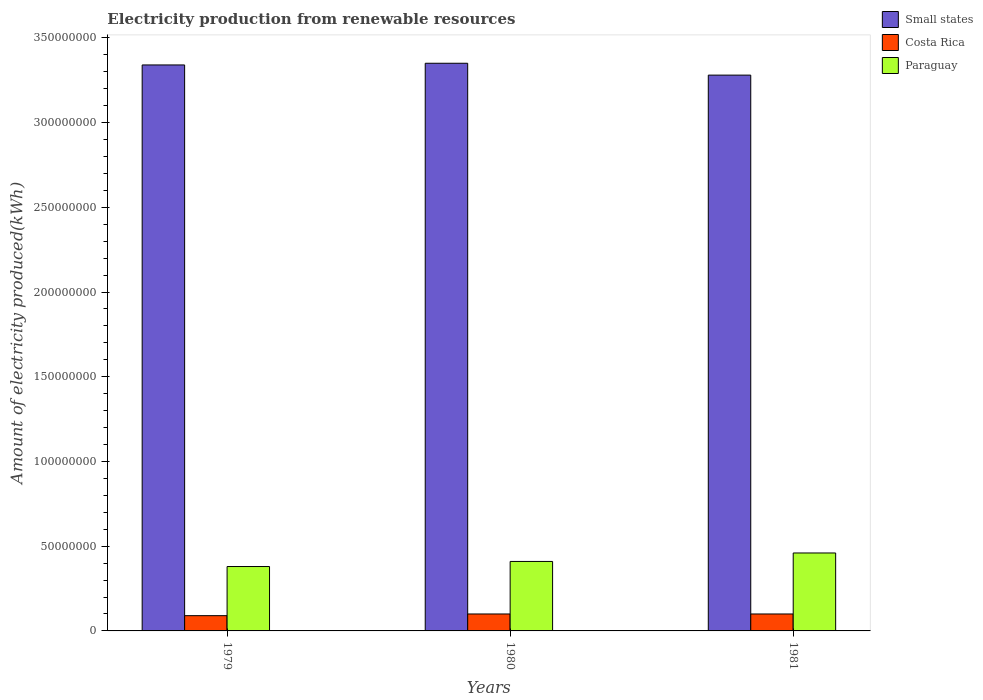How many different coloured bars are there?
Your response must be concise. 3. Are the number of bars on each tick of the X-axis equal?
Offer a very short reply. Yes. How many bars are there on the 3rd tick from the left?
Offer a terse response. 3. How many bars are there on the 1st tick from the right?
Keep it short and to the point. 3. What is the label of the 1st group of bars from the left?
Your response must be concise. 1979. In how many cases, is the number of bars for a given year not equal to the number of legend labels?
Your answer should be compact. 0. What is the amount of electricity produced in Costa Rica in 1980?
Your response must be concise. 1.00e+07. Across all years, what is the minimum amount of electricity produced in Costa Rica?
Your response must be concise. 9.00e+06. In which year was the amount of electricity produced in Costa Rica minimum?
Your answer should be compact. 1979. What is the total amount of electricity produced in Small states in the graph?
Provide a short and direct response. 9.97e+08. What is the difference between the amount of electricity produced in Small states in 1979 and that in 1981?
Offer a very short reply. 6.00e+06. What is the difference between the amount of electricity produced in Costa Rica in 1981 and the amount of electricity produced in Paraguay in 1979?
Provide a succinct answer. -2.80e+07. What is the average amount of electricity produced in Costa Rica per year?
Your answer should be very brief. 9.67e+06. In the year 1979, what is the difference between the amount of electricity produced in Costa Rica and amount of electricity produced in Small states?
Provide a short and direct response. -3.25e+08. In how many years, is the amount of electricity produced in Paraguay greater than 50000000 kWh?
Your answer should be compact. 0. Is the difference between the amount of electricity produced in Costa Rica in 1980 and 1981 greater than the difference between the amount of electricity produced in Small states in 1980 and 1981?
Keep it short and to the point. No. What is the difference between the highest and the second highest amount of electricity produced in Small states?
Your response must be concise. 1.00e+06. What is the difference between the highest and the lowest amount of electricity produced in Small states?
Offer a very short reply. 7.00e+06. In how many years, is the amount of electricity produced in Small states greater than the average amount of electricity produced in Small states taken over all years?
Your answer should be very brief. 2. Is the sum of the amount of electricity produced in Paraguay in 1979 and 1980 greater than the maximum amount of electricity produced in Costa Rica across all years?
Your answer should be very brief. Yes. What does the 3rd bar from the left in 1979 represents?
Your answer should be very brief. Paraguay. What does the 2nd bar from the right in 1981 represents?
Your answer should be very brief. Costa Rica. Is it the case that in every year, the sum of the amount of electricity produced in Paraguay and amount of electricity produced in Costa Rica is greater than the amount of electricity produced in Small states?
Your answer should be very brief. No. Are all the bars in the graph horizontal?
Your answer should be very brief. No. Are the values on the major ticks of Y-axis written in scientific E-notation?
Make the answer very short. No. Does the graph contain any zero values?
Offer a very short reply. No. Where does the legend appear in the graph?
Offer a very short reply. Top right. How many legend labels are there?
Provide a succinct answer. 3. How are the legend labels stacked?
Offer a terse response. Vertical. What is the title of the graph?
Your answer should be compact. Electricity production from renewable resources. What is the label or title of the Y-axis?
Provide a succinct answer. Amount of electricity produced(kWh). What is the Amount of electricity produced(kWh) in Small states in 1979?
Your answer should be very brief. 3.34e+08. What is the Amount of electricity produced(kWh) in Costa Rica in 1979?
Ensure brevity in your answer.  9.00e+06. What is the Amount of electricity produced(kWh) of Paraguay in 1979?
Ensure brevity in your answer.  3.80e+07. What is the Amount of electricity produced(kWh) in Small states in 1980?
Provide a short and direct response. 3.35e+08. What is the Amount of electricity produced(kWh) of Costa Rica in 1980?
Give a very brief answer. 1.00e+07. What is the Amount of electricity produced(kWh) of Paraguay in 1980?
Ensure brevity in your answer.  4.10e+07. What is the Amount of electricity produced(kWh) in Small states in 1981?
Your answer should be very brief. 3.28e+08. What is the Amount of electricity produced(kWh) in Costa Rica in 1981?
Keep it short and to the point. 1.00e+07. What is the Amount of electricity produced(kWh) of Paraguay in 1981?
Keep it short and to the point. 4.60e+07. Across all years, what is the maximum Amount of electricity produced(kWh) in Small states?
Provide a succinct answer. 3.35e+08. Across all years, what is the maximum Amount of electricity produced(kWh) of Costa Rica?
Your answer should be very brief. 1.00e+07. Across all years, what is the maximum Amount of electricity produced(kWh) of Paraguay?
Ensure brevity in your answer.  4.60e+07. Across all years, what is the minimum Amount of electricity produced(kWh) of Small states?
Provide a succinct answer. 3.28e+08. Across all years, what is the minimum Amount of electricity produced(kWh) in Costa Rica?
Provide a succinct answer. 9.00e+06. Across all years, what is the minimum Amount of electricity produced(kWh) of Paraguay?
Ensure brevity in your answer.  3.80e+07. What is the total Amount of electricity produced(kWh) in Small states in the graph?
Provide a short and direct response. 9.97e+08. What is the total Amount of electricity produced(kWh) of Costa Rica in the graph?
Offer a very short reply. 2.90e+07. What is the total Amount of electricity produced(kWh) in Paraguay in the graph?
Keep it short and to the point. 1.25e+08. What is the difference between the Amount of electricity produced(kWh) in Costa Rica in 1979 and that in 1981?
Offer a terse response. -1.00e+06. What is the difference between the Amount of electricity produced(kWh) in Paraguay in 1979 and that in 1981?
Give a very brief answer. -8.00e+06. What is the difference between the Amount of electricity produced(kWh) of Small states in 1980 and that in 1981?
Offer a terse response. 7.00e+06. What is the difference between the Amount of electricity produced(kWh) of Costa Rica in 1980 and that in 1981?
Your answer should be compact. 0. What is the difference between the Amount of electricity produced(kWh) in Paraguay in 1980 and that in 1981?
Your response must be concise. -5.00e+06. What is the difference between the Amount of electricity produced(kWh) of Small states in 1979 and the Amount of electricity produced(kWh) of Costa Rica in 1980?
Your answer should be very brief. 3.24e+08. What is the difference between the Amount of electricity produced(kWh) in Small states in 1979 and the Amount of electricity produced(kWh) in Paraguay in 1980?
Your answer should be compact. 2.93e+08. What is the difference between the Amount of electricity produced(kWh) of Costa Rica in 1979 and the Amount of electricity produced(kWh) of Paraguay in 1980?
Your response must be concise. -3.20e+07. What is the difference between the Amount of electricity produced(kWh) of Small states in 1979 and the Amount of electricity produced(kWh) of Costa Rica in 1981?
Provide a succinct answer. 3.24e+08. What is the difference between the Amount of electricity produced(kWh) of Small states in 1979 and the Amount of electricity produced(kWh) of Paraguay in 1981?
Offer a very short reply. 2.88e+08. What is the difference between the Amount of electricity produced(kWh) in Costa Rica in 1979 and the Amount of electricity produced(kWh) in Paraguay in 1981?
Offer a very short reply. -3.70e+07. What is the difference between the Amount of electricity produced(kWh) of Small states in 1980 and the Amount of electricity produced(kWh) of Costa Rica in 1981?
Your answer should be very brief. 3.25e+08. What is the difference between the Amount of electricity produced(kWh) of Small states in 1980 and the Amount of electricity produced(kWh) of Paraguay in 1981?
Your response must be concise. 2.89e+08. What is the difference between the Amount of electricity produced(kWh) in Costa Rica in 1980 and the Amount of electricity produced(kWh) in Paraguay in 1981?
Provide a short and direct response. -3.60e+07. What is the average Amount of electricity produced(kWh) in Small states per year?
Keep it short and to the point. 3.32e+08. What is the average Amount of electricity produced(kWh) of Costa Rica per year?
Your answer should be very brief. 9.67e+06. What is the average Amount of electricity produced(kWh) in Paraguay per year?
Offer a very short reply. 4.17e+07. In the year 1979, what is the difference between the Amount of electricity produced(kWh) in Small states and Amount of electricity produced(kWh) in Costa Rica?
Offer a terse response. 3.25e+08. In the year 1979, what is the difference between the Amount of electricity produced(kWh) in Small states and Amount of electricity produced(kWh) in Paraguay?
Give a very brief answer. 2.96e+08. In the year 1979, what is the difference between the Amount of electricity produced(kWh) in Costa Rica and Amount of electricity produced(kWh) in Paraguay?
Your response must be concise. -2.90e+07. In the year 1980, what is the difference between the Amount of electricity produced(kWh) in Small states and Amount of electricity produced(kWh) in Costa Rica?
Offer a terse response. 3.25e+08. In the year 1980, what is the difference between the Amount of electricity produced(kWh) in Small states and Amount of electricity produced(kWh) in Paraguay?
Keep it short and to the point. 2.94e+08. In the year 1980, what is the difference between the Amount of electricity produced(kWh) in Costa Rica and Amount of electricity produced(kWh) in Paraguay?
Ensure brevity in your answer.  -3.10e+07. In the year 1981, what is the difference between the Amount of electricity produced(kWh) in Small states and Amount of electricity produced(kWh) in Costa Rica?
Your answer should be very brief. 3.18e+08. In the year 1981, what is the difference between the Amount of electricity produced(kWh) in Small states and Amount of electricity produced(kWh) in Paraguay?
Keep it short and to the point. 2.82e+08. In the year 1981, what is the difference between the Amount of electricity produced(kWh) of Costa Rica and Amount of electricity produced(kWh) of Paraguay?
Keep it short and to the point. -3.60e+07. What is the ratio of the Amount of electricity produced(kWh) of Small states in 1979 to that in 1980?
Offer a terse response. 1. What is the ratio of the Amount of electricity produced(kWh) of Costa Rica in 1979 to that in 1980?
Offer a terse response. 0.9. What is the ratio of the Amount of electricity produced(kWh) in Paraguay in 1979 to that in 1980?
Provide a short and direct response. 0.93. What is the ratio of the Amount of electricity produced(kWh) of Small states in 1979 to that in 1981?
Make the answer very short. 1.02. What is the ratio of the Amount of electricity produced(kWh) of Paraguay in 1979 to that in 1981?
Provide a short and direct response. 0.83. What is the ratio of the Amount of electricity produced(kWh) in Small states in 1980 to that in 1981?
Provide a short and direct response. 1.02. What is the ratio of the Amount of electricity produced(kWh) in Paraguay in 1980 to that in 1981?
Ensure brevity in your answer.  0.89. What is the difference between the highest and the second highest Amount of electricity produced(kWh) in Costa Rica?
Ensure brevity in your answer.  0. What is the difference between the highest and the lowest Amount of electricity produced(kWh) of Costa Rica?
Keep it short and to the point. 1.00e+06. What is the difference between the highest and the lowest Amount of electricity produced(kWh) in Paraguay?
Your response must be concise. 8.00e+06. 